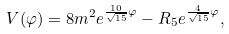Convert formula to latex. <formula><loc_0><loc_0><loc_500><loc_500>V ( \varphi ) = 8 m ^ { 2 } e ^ { { \frac { 1 0 } { \sqrt { 1 5 } } } \varphi } - R _ { 5 } e ^ { { \frac { 4 } { \sqrt { 1 5 } } } \varphi } ,</formula> 